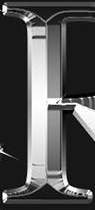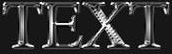Transcribe the words shown in these images in order, separated by a semicolon. #; TEXT 